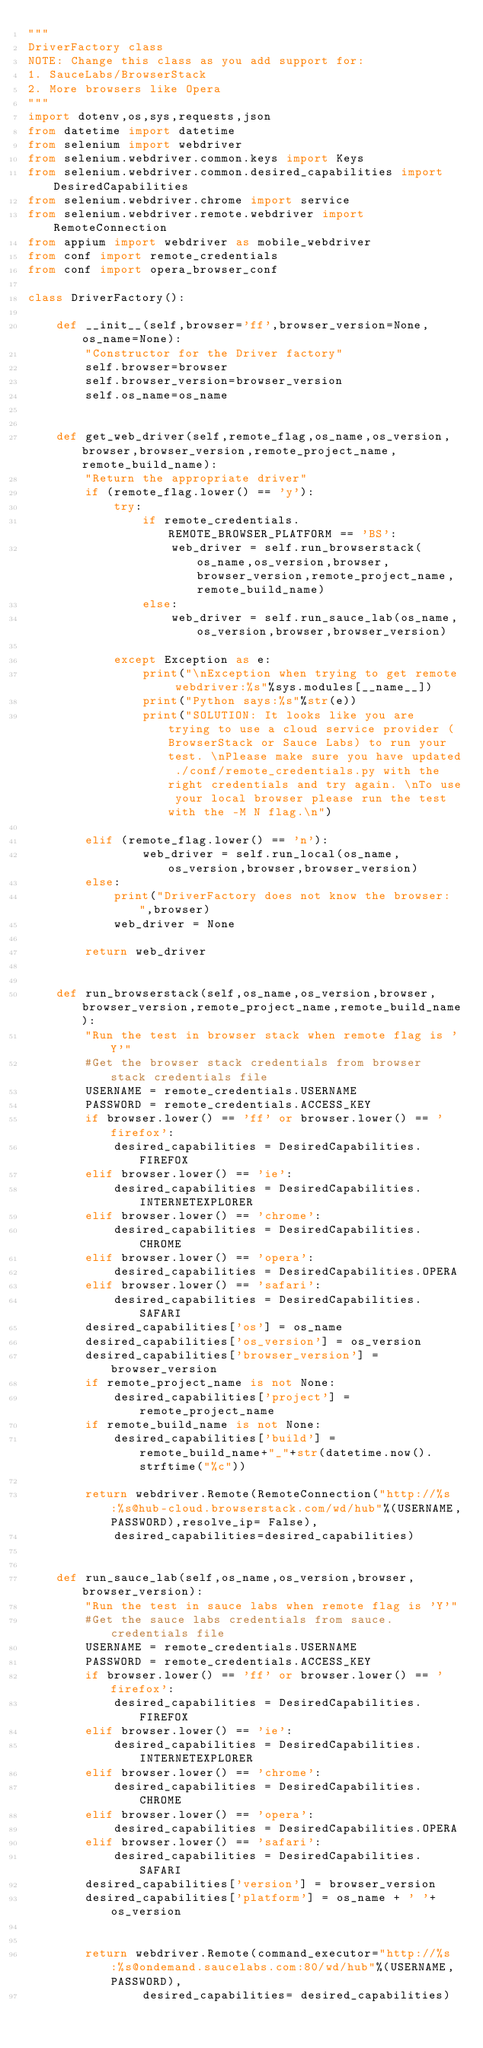Convert code to text. <code><loc_0><loc_0><loc_500><loc_500><_Python_>"""
DriverFactory class
NOTE: Change this class as you add support for:
1. SauceLabs/BrowserStack
2. More browsers like Opera
"""
import dotenv,os,sys,requests,json
from datetime import datetime
from selenium import webdriver
from selenium.webdriver.common.keys import Keys
from selenium.webdriver.common.desired_capabilities import DesiredCapabilities
from selenium.webdriver.chrome import service
from selenium.webdriver.remote.webdriver import RemoteConnection
from appium import webdriver as mobile_webdriver
from conf import remote_credentials
from conf import opera_browser_conf

class DriverFactory():
    
    def __init__(self,browser='ff',browser_version=None,os_name=None):
        "Constructor for the Driver factory"
        self.browser=browser
        self.browser_version=browser_version
        self.os_name=os_name

        
    def get_web_driver(self,remote_flag,os_name,os_version,browser,browser_version,remote_project_name,remote_build_name):
        "Return the appropriate driver"
        if (remote_flag.lower() == 'y'):
            try:
                if remote_credentials.REMOTE_BROWSER_PLATFORM == 'BS':
                    web_driver = self.run_browserstack(os_name,os_version,browser,browser_version,remote_project_name,remote_build_name)
                else:
                    web_driver = self.run_sauce_lab(os_name,os_version,browser,browser_version)
                    
            except Exception as e:
                print("\nException when trying to get remote webdriver:%s"%sys.modules[__name__])
                print("Python says:%s"%str(e))
                print("SOLUTION: It looks like you are trying to use a cloud service provider (BrowserStack or Sauce Labs) to run your test. \nPlease make sure you have updated ./conf/remote_credentials.py with the right credentials and try again. \nTo use your local browser please run the test with the -M N flag.\n")
                
        elif (remote_flag.lower() == 'n'):
                web_driver = self.run_local(os_name,os_version,browser,browser_version)       
        else:
            print("DriverFactory does not know the browser: ",browser)
            web_driver = None

        return web_driver   
    

    def run_browserstack(self,os_name,os_version,browser,browser_version,remote_project_name,remote_build_name):
        "Run the test in browser stack when remote flag is 'Y'"
        #Get the browser stack credentials from browser stack credentials file
        USERNAME = remote_credentials.USERNAME
        PASSWORD = remote_credentials.ACCESS_KEY
        if browser.lower() == 'ff' or browser.lower() == 'firefox':
            desired_capabilities = DesiredCapabilities.FIREFOX            
        elif browser.lower() == 'ie':
            desired_capabilities = DesiredCapabilities.INTERNETEXPLORER
        elif browser.lower() == 'chrome':
            desired_capabilities = DesiredCapabilities.CHROME            
        elif browser.lower() == 'opera':
            desired_capabilities = DesiredCapabilities.OPERA        
        elif browser.lower() == 'safari':
            desired_capabilities = DesiredCapabilities.SAFARI
        desired_capabilities['os'] = os_name
        desired_capabilities['os_version'] = os_version
        desired_capabilities['browser_version'] = browser_version
        if remote_project_name is not None:
            desired_capabilities['project'] = remote_project_name
        if remote_build_name is not None:
            desired_capabilities['build'] = remote_build_name+"_"+str(datetime.now().strftime("%c"))

        return webdriver.Remote(RemoteConnection("http://%s:%s@hub-cloud.browserstack.com/wd/hub"%(USERNAME,PASSWORD),resolve_ip= False),
            desired_capabilities=desired_capabilities)
    

    def run_sauce_lab(self,os_name,os_version,browser,browser_version):
        "Run the test in sauce labs when remote flag is 'Y'"
        #Get the sauce labs credentials from sauce.credentials file
        USERNAME = remote_credentials.USERNAME
        PASSWORD = remote_credentials.ACCESS_KEY
        if browser.lower() == 'ff' or browser.lower() == 'firefox':
            desired_capabilities = DesiredCapabilities.FIREFOX            
        elif browser.lower() == 'ie':
            desired_capabilities = DesiredCapabilities.INTERNETEXPLORER
        elif browser.lower() == 'chrome':
            desired_capabilities = DesiredCapabilities.CHROME            
        elif browser.lower() == 'opera':
            desired_capabilities = DesiredCapabilities.OPERA        
        elif browser.lower() == 'safari':
            desired_capabilities = DesiredCapabilities.SAFARI
        desired_capabilities['version'] = browser_version
        desired_capabilities['platform'] = os_name + ' '+os_version
        
        
        return webdriver.Remote(command_executor="http://%s:%s@ondemand.saucelabs.com:80/wd/hub"%(USERNAME,PASSWORD),
                desired_capabilities= desired_capabilities)

</code> 